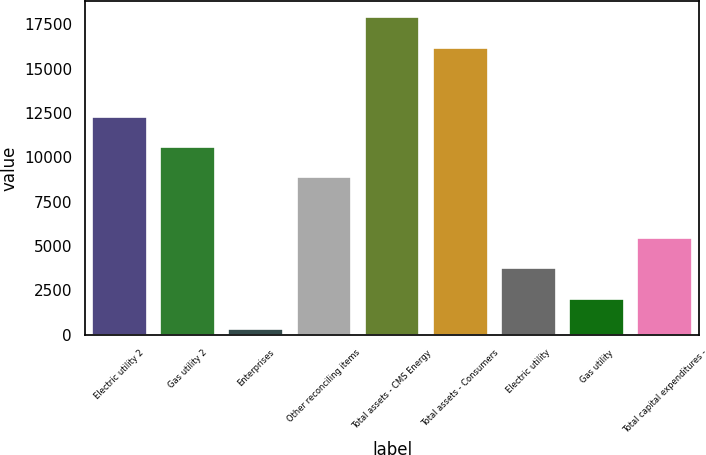Convert chart to OTSL. <chart><loc_0><loc_0><loc_500><loc_500><bar_chart><fcel>Electric utility 2<fcel>Gas utility 2<fcel>Enterprises<fcel>Other reconciling items<fcel>Total assets - CMS Energy<fcel>Total assets - Consumers<fcel>Electric utility<fcel>Gas utility<fcel>Total capital expenditures -<nl><fcel>12290.8<fcel>10582.4<fcel>332<fcel>8874<fcel>17887.4<fcel>16179<fcel>3748.8<fcel>2040.4<fcel>5457.2<nl></chart> 